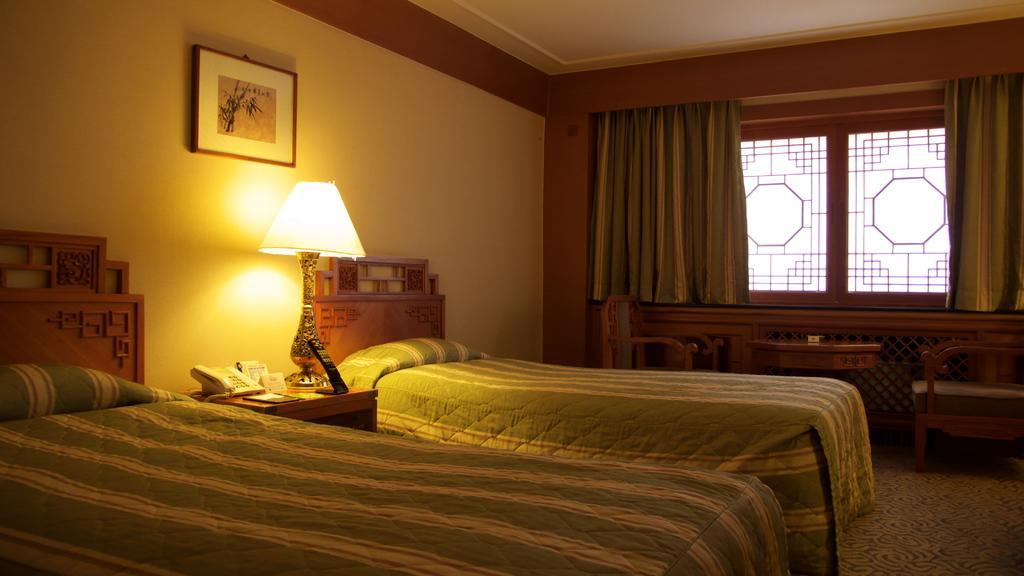How would you summarize this image in a sentence or two? In this picture we can see the windows, curtains. We can see a frame on the wall. We can see chairs and table on the floor. We can see the beds with the mattress. On a table we can see a telephone, bed lamp and few other objects. 